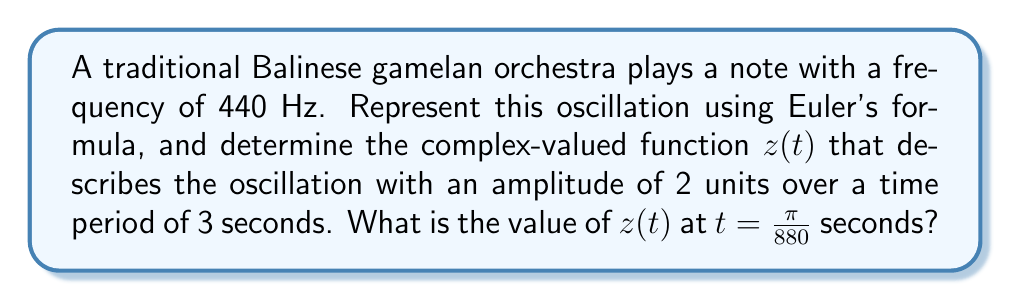Teach me how to tackle this problem. Let's approach this step-by-step:

1) Euler's formula states that $e^{ix} = \cos x + i \sin x$

2) For a harmonic oscillation, we can represent it as:
   $z(t) = Ae^{i\omega t}$
   where $A$ is the amplitude and $\omega$ is the angular frequency

3) We're given:
   - Frequency $f = 440$ Hz
   - Amplitude $A = 2$ units
   - Angular frequency $\omega = 2\pi f = 2\pi(440) = 880\pi$ rad/s

4) Therefore, our complex-valued function is:
   $z(t) = 2e^{880\pi i t}$

5) To find $z(t)$ at $t = \frac{\pi}{880}$ seconds:
   $z(\frac{\pi}{880}) = 2e^{880\pi i (\frac{\pi}{880})}$
                       $= 2e^{\pi^2 i}$

6) Using Euler's formula:
   $z(\frac{\pi}{880}) = 2(\cos(\pi^2) + i\sin(\pi^2))$

7) We know that $\cos(\pi^2) \approx -1$ and $\sin(\pi^2) \approx 0$

8) Therefore:
   $z(\frac{\pi}{880}) \approx 2(-1 + 0i) = -2$
Answer: $-2$ 